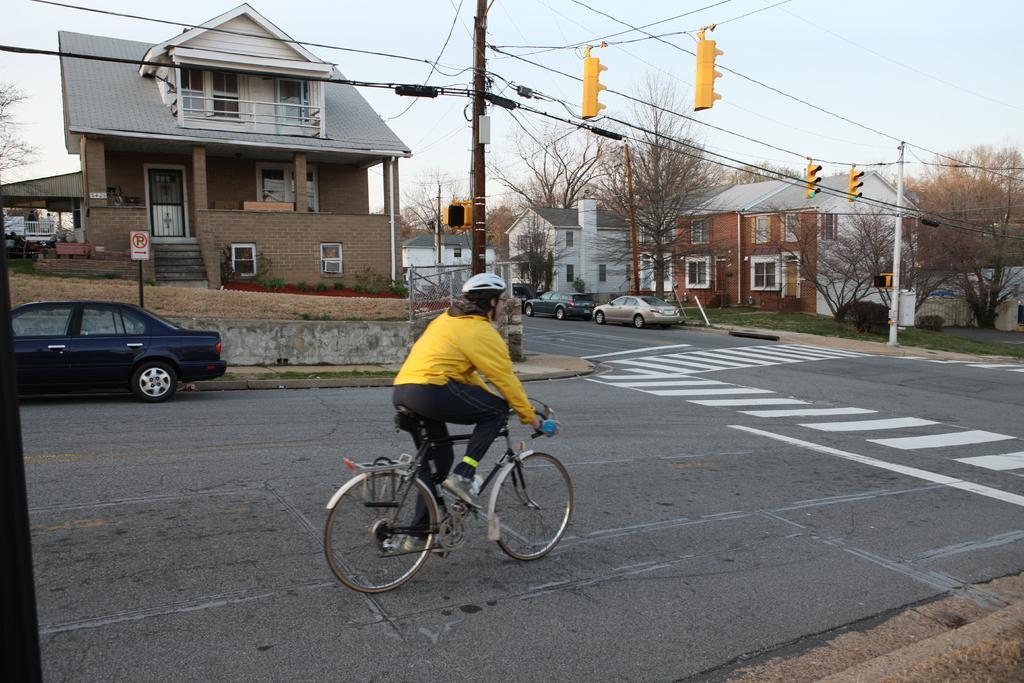Please provide a concise description of this image. This image consists of a woman riding a bicycle. At the bottom, there is a road. On the left, we can see a car in black color. On the right, there are houses and cars along with the trees. In the front, there is a house. At the top, there is a sky. And there are traffic lights changed to the wires. 